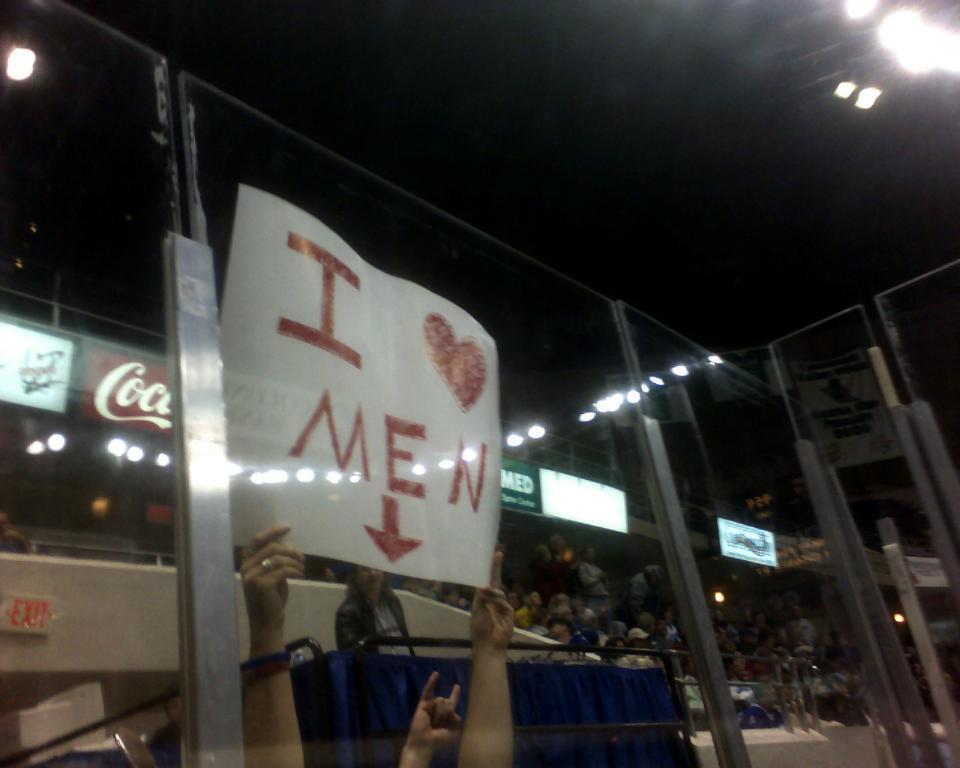In one or two sentences, can you explain what this image depicts? In this picture we can see only person hands and the person is holding a board. In front of the person they are looking like glasses and poles. Behind the person there are a group of people, boards and lights. Behind the boards, there is the dark background. 